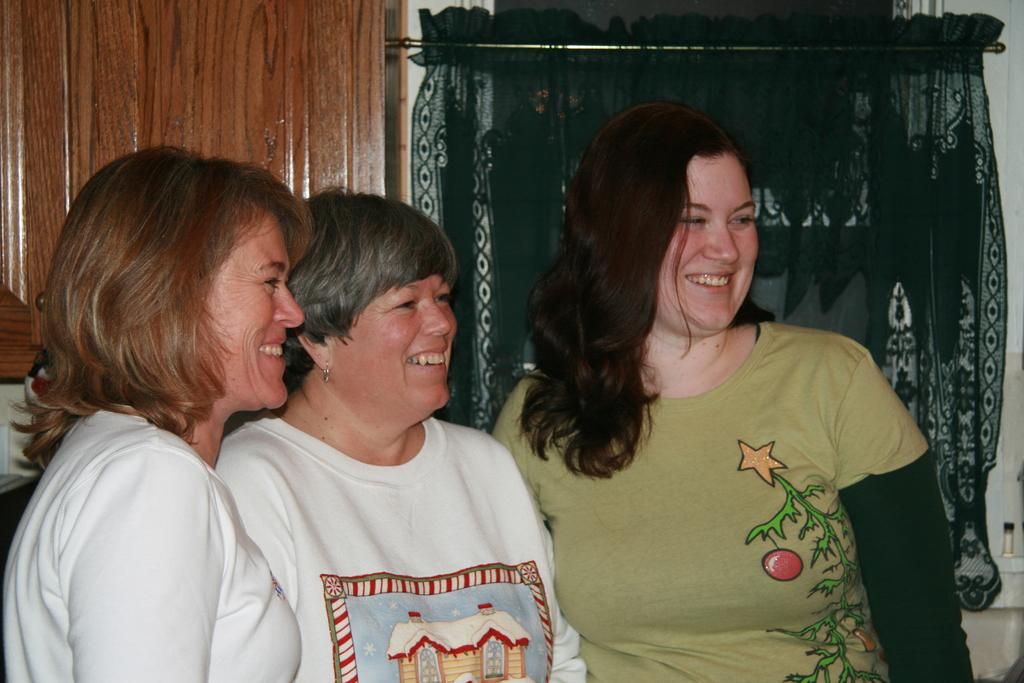Who is present in the foreground of the image? There are women standing in the foreground of the image. What are the women doing in the image? The women are laughing. What can be seen in the background of the image? There is a wall in the background of the image. What type of curtain is present in the image? There is a green color curtain. What material is the window made of in the image? The window is made of wood. Can you see any waves crashing against the shore in the image? There are no waves or shore visible in the image; it features women standing and laughing with a wall and a wooden window in the background. 